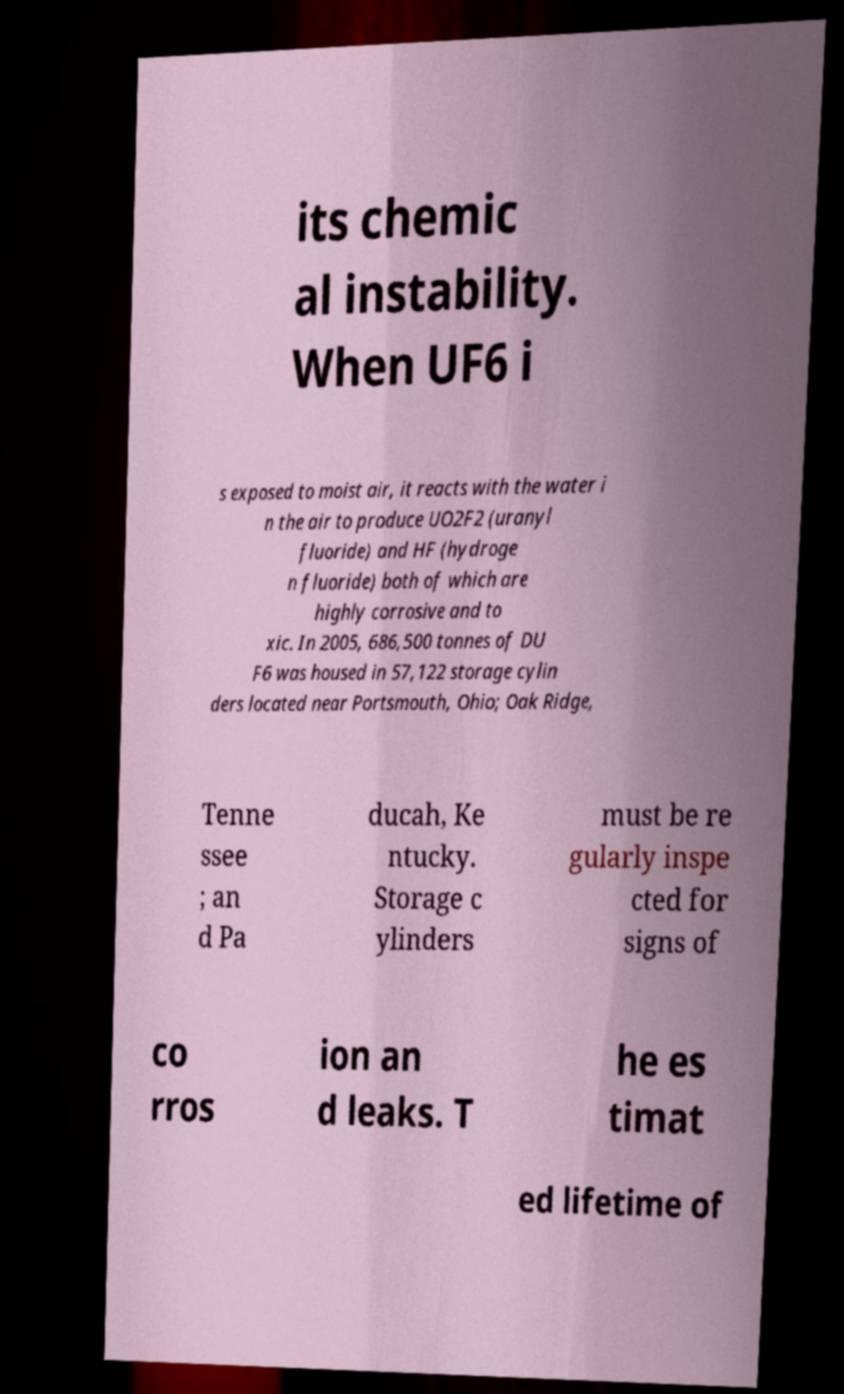For documentation purposes, I need the text within this image transcribed. Could you provide that? its chemic al instability. When UF6 i s exposed to moist air, it reacts with the water i n the air to produce UO2F2 (uranyl fluoride) and HF (hydroge n fluoride) both of which are highly corrosive and to xic. In 2005, 686,500 tonnes of DU F6 was housed in 57,122 storage cylin ders located near Portsmouth, Ohio; Oak Ridge, Tenne ssee ; an d Pa ducah, Ke ntucky. Storage c ylinders must be re gularly inspe cted for signs of co rros ion an d leaks. T he es timat ed lifetime of 